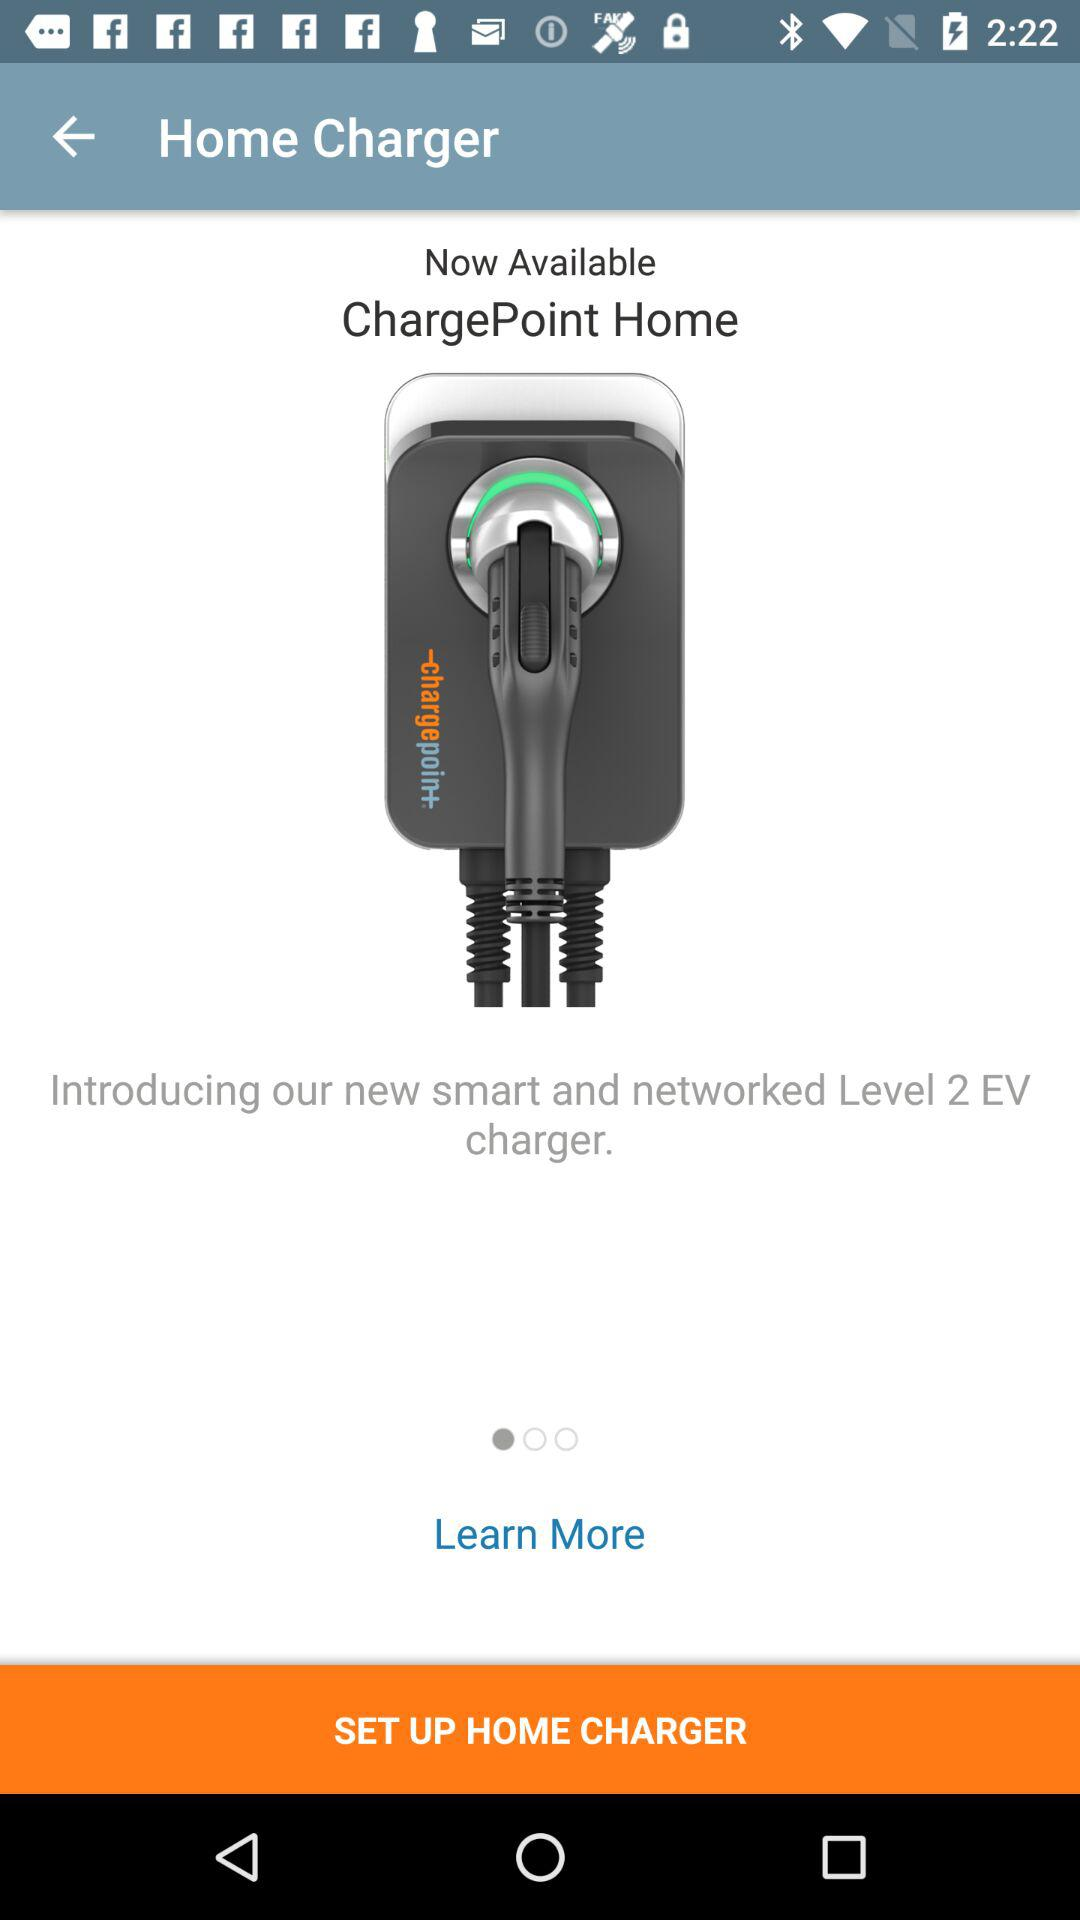What is the name of the product? The name of the product is "ChargePoint Home". 